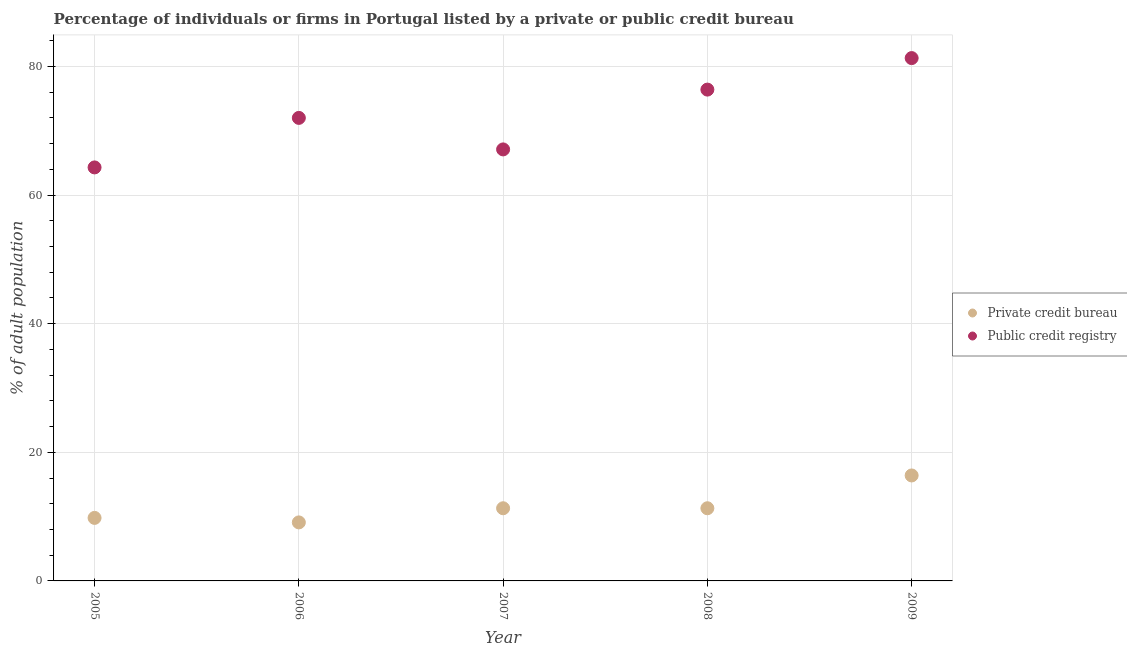How many different coloured dotlines are there?
Your response must be concise. 2. Is the number of dotlines equal to the number of legend labels?
Your answer should be very brief. Yes. Across all years, what is the minimum percentage of firms listed by public credit bureau?
Keep it short and to the point. 64.3. In which year was the percentage of firms listed by private credit bureau maximum?
Your answer should be very brief. 2009. What is the total percentage of firms listed by private credit bureau in the graph?
Provide a succinct answer. 57.9. What is the difference between the percentage of firms listed by private credit bureau in 2008 and that in 2009?
Ensure brevity in your answer.  -5.1. What is the difference between the percentage of firms listed by public credit bureau in 2005 and the percentage of firms listed by private credit bureau in 2009?
Offer a very short reply. 47.9. What is the average percentage of firms listed by private credit bureau per year?
Offer a very short reply. 11.58. In the year 2005, what is the difference between the percentage of firms listed by private credit bureau and percentage of firms listed by public credit bureau?
Provide a succinct answer. -54.5. What is the ratio of the percentage of firms listed by public credit bureau in 2005 to that in 2008?
Provide a succinct answer. 0.84. Is the percentage of firms listed by private credit bureau in 2006 less than that in 2007?
Offer a very short reply. Yes. Is the difference between the percentage of firms listed by public credit bureau in 2006 and 2009 greater than the difference between the percentage of firms listed by private credit bureau in 2006 and 2009?
Provide a short and direct response. No. What is the difference between the highest and the second highest percentage of firms listed by private credit bureau?
Your answer should be compact. 5.1. What is the difference between the highest and the lowest percentage of firms listed by private credit bureau?
Keep it short and to the point. 7.3. Is the sum of the percentage of firms listed by public credit bureau in 2005 and 2008 greater than the maximum percentage of firms listed by private credit bureau across all years?
Your response must be concise. Yes. Is the percentage of firms listed by public credit bureau strictly greater than the percentage of firms listed by private credit bureau over the years?
Your answer should be compact. Yes. How many dotlines are there?
Your answer should be compact. 2. How many years are there in the graph?
Your answer should be very brief. 5. What is the difference between two consecutive major ticks on the Y-axis?
Keep it short and to the point. 20. Are the values on the major ticks of Y-axis written in scientific E-notation?
Your response must be concise. No. Does the graph contain any zero values?
Provide a short and direct response. No. How many legend labels are there?
Offer a very short reply. 2. What is the title of the graph?
Ensure brevity in your answer.  Percentage of individuals or firms in Portugal listed by a private or public credit bureau. What is the label or title of the Y-axis?
Offer a very short reply. % of adult population. What is the % of adult population of Private credit bureau in 2005?
Provide a succinct answer. 9.8. What is the % of adult population in Public credit registry in 2005?
Your answer should be compact. 64.3. What is the % of adult population of Private credit bureau in 2006?
Ensure brevity in your answer.  9.1. What is the % of adult population in Public credit registry in 2006?
Make the answer very short. 72. What is the % of adult population in Public credit registry in 2007?
Offer a very short reply. 67.1. What is the % of adult population in Public credit registry in 2008?
Your response must be concise. 76.4. What is the % of adult population in Public credit registry in 2009?
Give a very brief answer. 81.3. Across all years, what is the maximum % of adult population in Public credit registry?
Offer a terse response. 81.3. Across all years, what is the minimum % of adult population of Public credit registry?
Your response must be concise. 64.3. What is the total % of adult population of Private credit bureau in the graph?
Offer a terse response. 57.9. What is the total % of adult population in Public credit registry in the graph?
Keep it short and to the point. 361.1. What is the difference between the % of adult population of Private credit bureau in 2005 and that in 2006?
Provide a succinct answer. 0.7. What is the difference between the % of adult population of Public credit registry in 2006 and that in 2007?
Provide a succinct answer. 4.9. What is the difference between the % of adult population in Private credit bureau in 2005 and the % of adult population in Public credit registry in 2006?
Your answer should be very brief. -62.2. What is the difference between the % of adult population in Private credit bureau in 2005 and the % of adult population in Public credit registry in 2007?
Keep it short and to the point. -57.3. What is the difference between the % of adult population in Private credit bureau in 2005 and the % of adult population in Public credit registry in 2008?
Your response must be concise. -66.6. What is the difference between the % of adult population of Private credit bureau in 2005 and the % of adult population of Public credit registry in 2009?
Provide a short and direct response. -71.5. What is the difference between the % of adult population in Private credit bureau in 2006 and the % of adult population in Public credit registry in 2007?
Make the answer very short. -58. What is the difference between the % of adult population in Private credit bureau in 2006 and the % of adult population in Public credit registry in 2008?
Provide a succinct answer. -67.3. What is the difference between the % of adult population in Private credit bureau in 2006 and the % of adult population in Public credit registry in 2009?
Offer a terse response. -72.2. What is the difference between the % of adult population of Private credit bureau in 2007 and the % of adult population of Public credit registry in 2008?
Offer a very short reply. -65.1. What is the difference between the % of adult population of Private credit bureau in 2007 and the % of adult population of Public credit registry in 2009?
Your response must be concise. -70. What is the difference between the % of adult population of Private credit bureau in 2008 and the % of adult population of Public credit registry in 2009?
Your answer should be very brief. -70. What is the average % of adult population of Private credit bureau per year?
Give a very brief answer. 11.58. What is the average % of adult population in Public credit registry per year?
Offer a very short reply. 72.22. In the year 2005, what is the difference between the % of adult population of Private credit bureau and % of adult population of Public credit registry?
Keep it short and to the point. -54.5. In the year 2006, what is the difference between the % of adult population in Private credit bureau and % of adult population in Public credit registry?
Ensure brevity in your answer.  -62.9. In the year 2007, what is the difference between the % of adult population of Private credit bureau and % of adult population of Public credit registry?
Your answer should be compact. -55.8. In the year 2008, what is the difference between the % of adult population in Private credit bureau and % of adult population in Public credit registry?
Provide a succinct answer. -65.1. In the year 2009, what is the difference between the % of adult population of Private credit bureau and % of adult population of Public credit registry?
Keep it short and to the point. -64.9. What is the ratio of the % of adult population of Public credit registry in 2005 to that in 2006?
Your response must be concise. 0.89. What is the ratio of the % of adult population in Private credit bureau in 2005 to that in 2007?
Provide a succinct answer. 0.87. What is the ratio of the % of adult population of Public credit registry in 2005 to that in 2007?
Provide a succinct answer. 0.96. What is the ratio of the % of adult population of Private credit bureau in 2005 to that in 2008?
Provide a succinct answer. 0.87. What is the ratio of the % of adult population of Public credit registry in 2005 to that in 2008?
Make the answer very short. 0.84. What is the ratio of the % of adult population in Private credit bureau in 2005 to that in 2009?
Ensure brevity in your answer.  0.6. What is the ratio of the % of adult population of Public credit registry in 2005 to that in 2009?
Offer a very short reply. 0.79. What is the ratio of the % of adult population in Private credit bureau in 2006 to that in 2007?
Your answer should be compact. 0.81. What is the ratio of the % of adult population of Public credit registry in 2006 to that in 2007?
Your answer should be compact. 1.07. What is the ratio of the % of adult population of Private credit bureau in 2006 to that in 2008?
Ensure brevity in your answer.  0.81. What is the ratio of the % of adult population in Public credit registry in 2006 to that in 2008?
Your answer should be compact. 0.94. What is the ratio of the % of adult population in Private credit bureau in 2006 to that in 2009?
Ensure brevity in your answer.  0.55. What is the ratio of the % of adult population of Public credit registry in 2006 to that in 2009?
Provide a short and direct response. 0.89. What is the ratio of the % of adult population in Public credit registry in 2007 to that in 2008?
Make the answer very short. 0.88. What is the ratio of the % of adult population of Private credit bureau in 2007 to that in 2009?
Make the answer very short. 0.69. What is the ratio of the % of adult population of Public credit registry in 2007 to that in 2009?
Your answer should be compact. 0.83. What is the ratio of the % of adult population in Private credit bureau in 2008 to that in 2009?
Your answer should be compact. 0.69. What is the ratio of the % of adult population of Public credit registry in 2008 to that in 2009?
Offer a very short reply. 0.94. What is the difference between the highest and the second highest % of adult population in Public credit registry?
Your response must be concise. 4.9. What is the difference between the highest and the lowest % of adult population of Public credit registry?
Give a very brief answer. 17. 